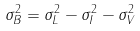<formula> <loc_0><loc_0><loc_500><loc_500>\sigma _ { B } ^ { 2 } = \sigma _ { L } ^ { 2 } - \sigma _ { I } ^ { 2 } - \sigma _ { V } ^ { 2 } \\</formula> 